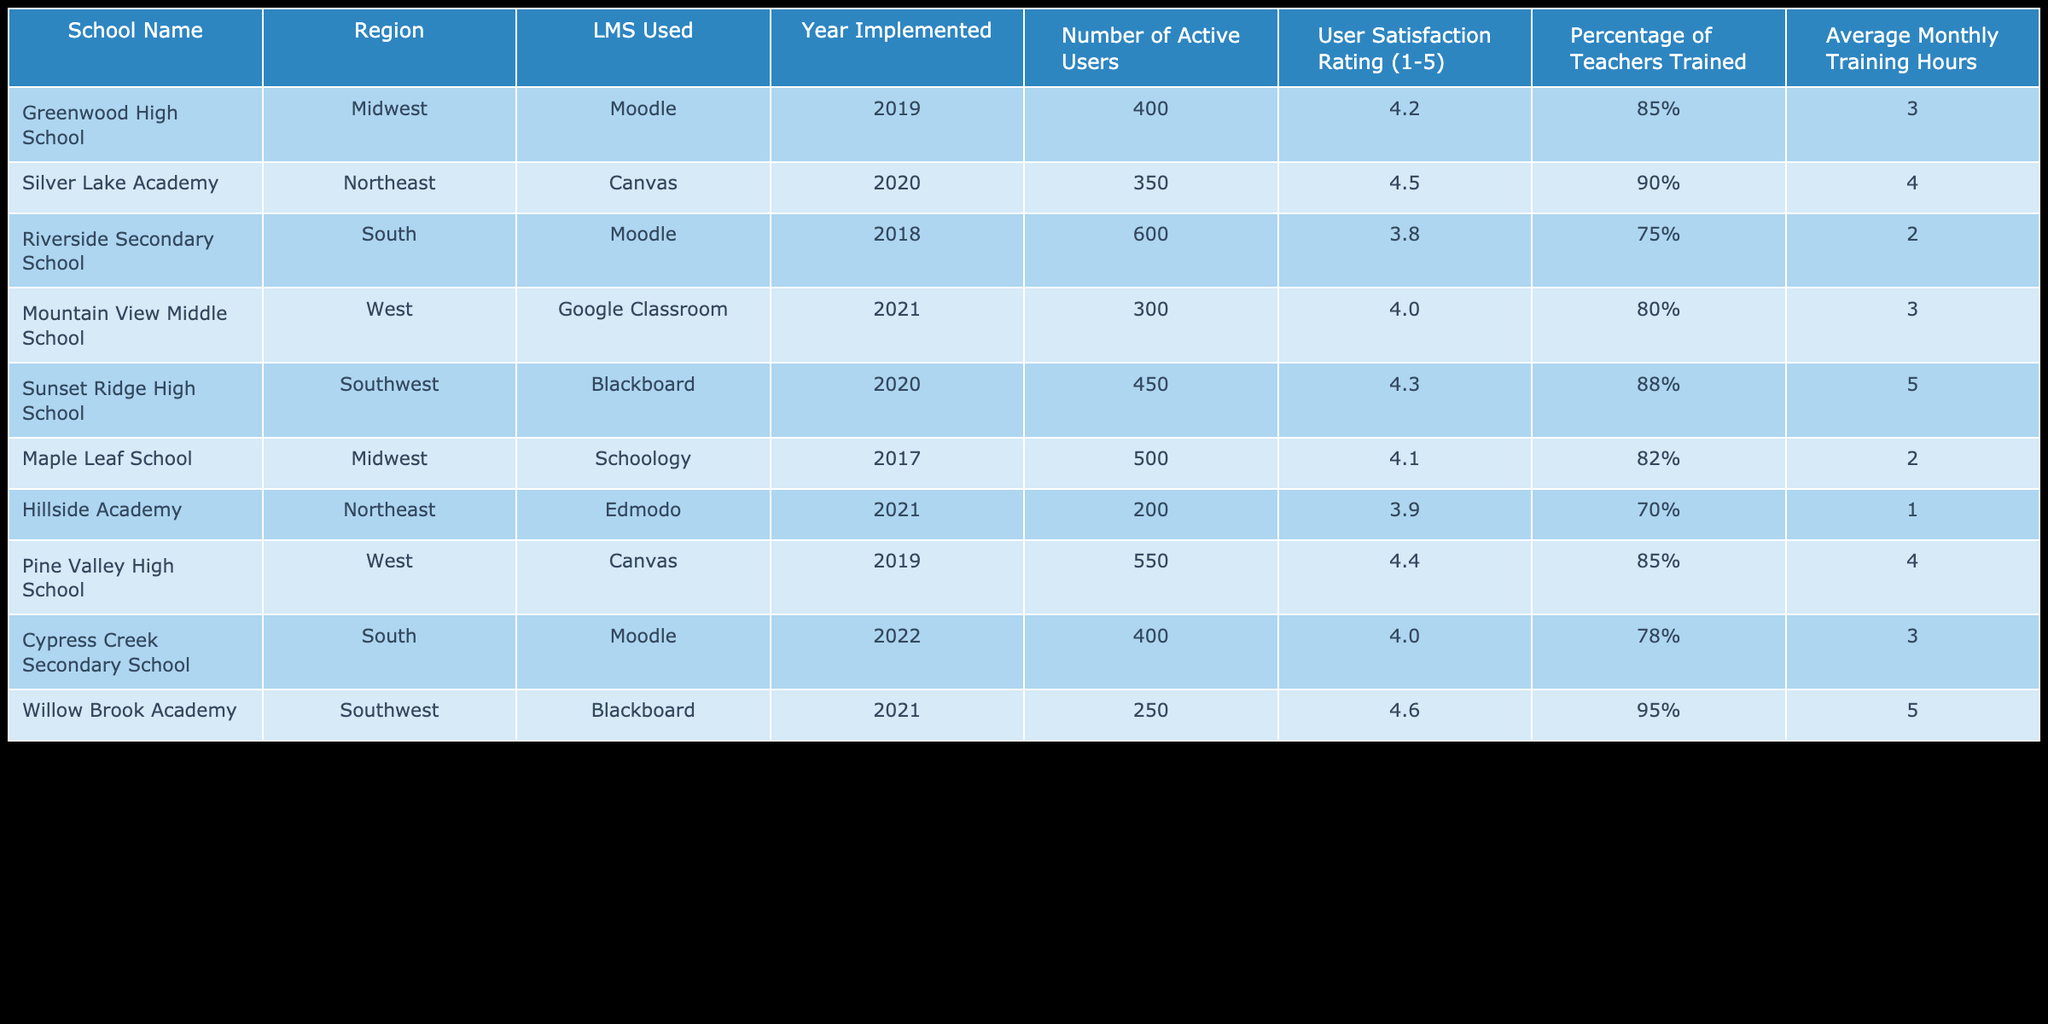What is the user satisfaction rating for Riverside Secondary School? The user satisfaction rating for Riverside Secondary School is explicitly listed in the table under the "User Satisfaction Rating (1-5)" column. It shows a rating of 3.8.
Answer: 3.8 Which Learning Management System has the most active users? By examining the "Number of Active Users" column, Riverside Secondary School has the highest number of active users with 600, indicating that Moodle is the LMS with the most active users in this dataset.
Answer: Moodle What is the average number of active users across all schools using Blackboard? The two schools using Blackboard are Sunset Ridge High School (450 active users) and Willow Brook Academy (250 active users). Adding these together gives 450 + 250 = 700. Dividing by 2 for the average results in 700 / 2 = 350.
Answer: 350 Is it true that all schools trained at least 70% of their teachers? By checking the "Percentage of Teachers Trained" column, all schools have percentages listed (85%, 90%, 75%, 80%, 88%, 82%, 70%, 78%, 95%), with the minimum being 70%. Therefore, it is true that all schools trained at least 70% of their teachers.
Answer: Yes Which region has the highest average user satisfaction rating? First, we gather satisfaction ratings by region: Midwest (4.2 and 4.1), Northeast (4.5 and 3.9), South (3.8, 4.0), Southwest (4.3, 4.6), West (4.0, 4.4). The average ratings calculated are: Midwest (4.15), Northeast (4.2), South (3.9), Southwest (4.45), West (4.2). The highest average is for the Southwest region with 4.45.
Answer: Southwest 